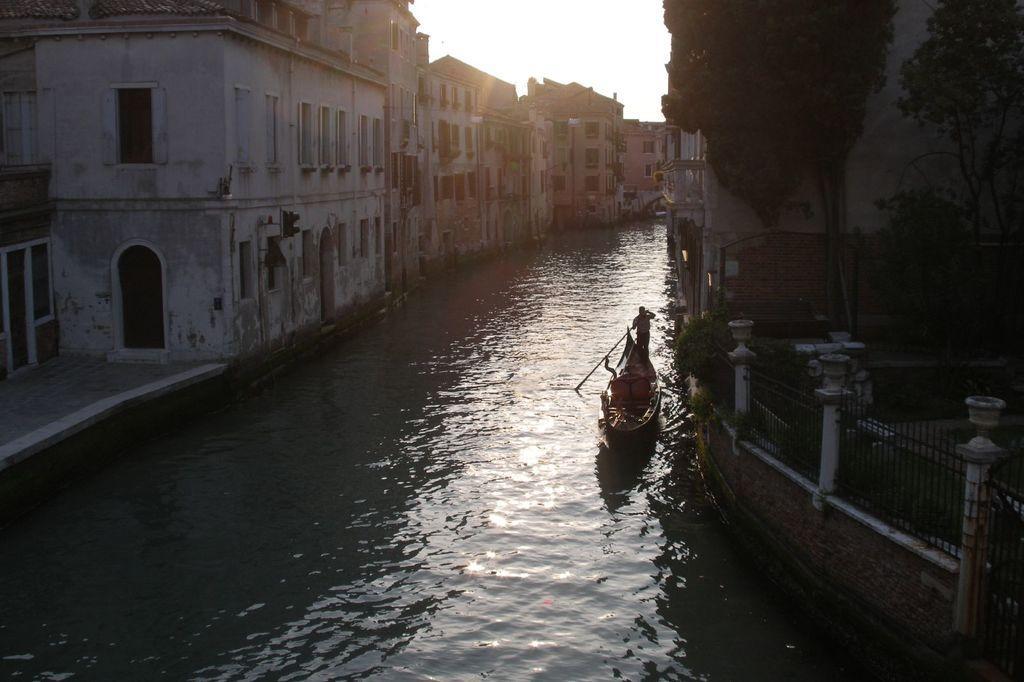Please provide a concise description of this image. In this picture we can see a boat on the water, beside the boat we can find few buildings and fence, we can see a person in the boat. 